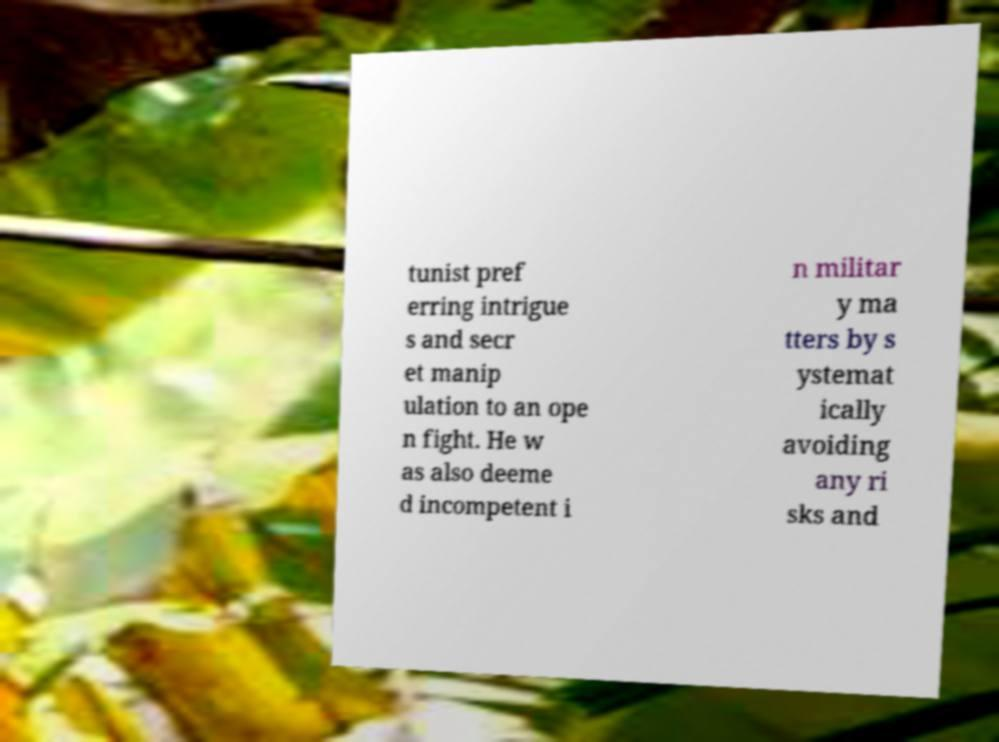Could you extract and type out the text from this image? tunist pref erring intrigue s and secr et manip ulation to an ope n fight. He w as also deeme d incompetent i n militar y ma tters by s ystemat ically avoiding any ri sks and 